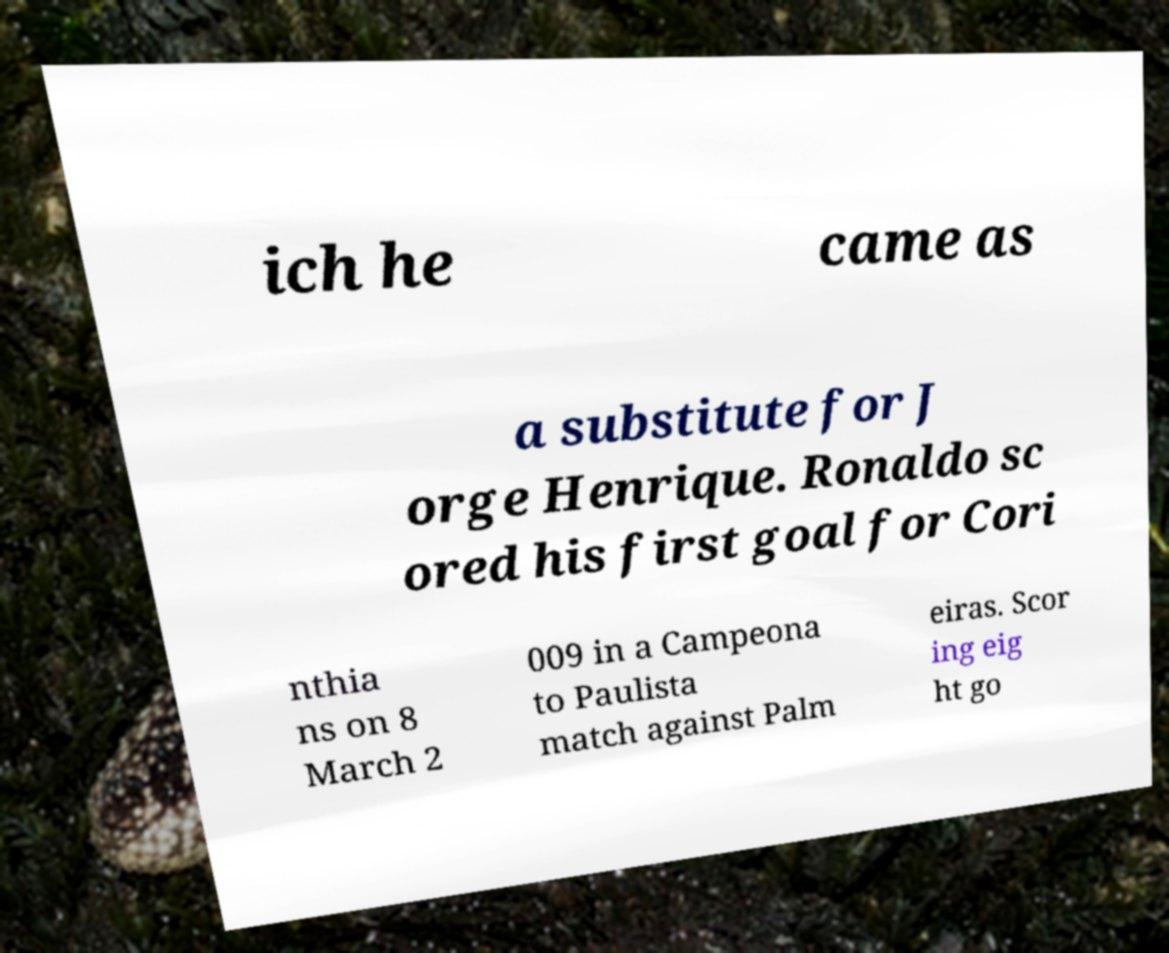What messages or text are displayed in this image? I need them in a readable, typed format. ich he came as a substitute for J orge Henrique. Ronaldo sc ored his first goal for Cori nthia ns on 8 March 2 009 in a Campeona to Paulista match against Palm eiras. Scor ing eig ht go 